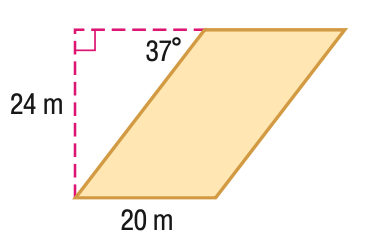Question: Find the area of the parallelogram. Round to the nearest tenth if necessary.
Choices:
A. 420
B. 480
C. 764.4
D. 797.6
Answer with the letter. Answer: B 